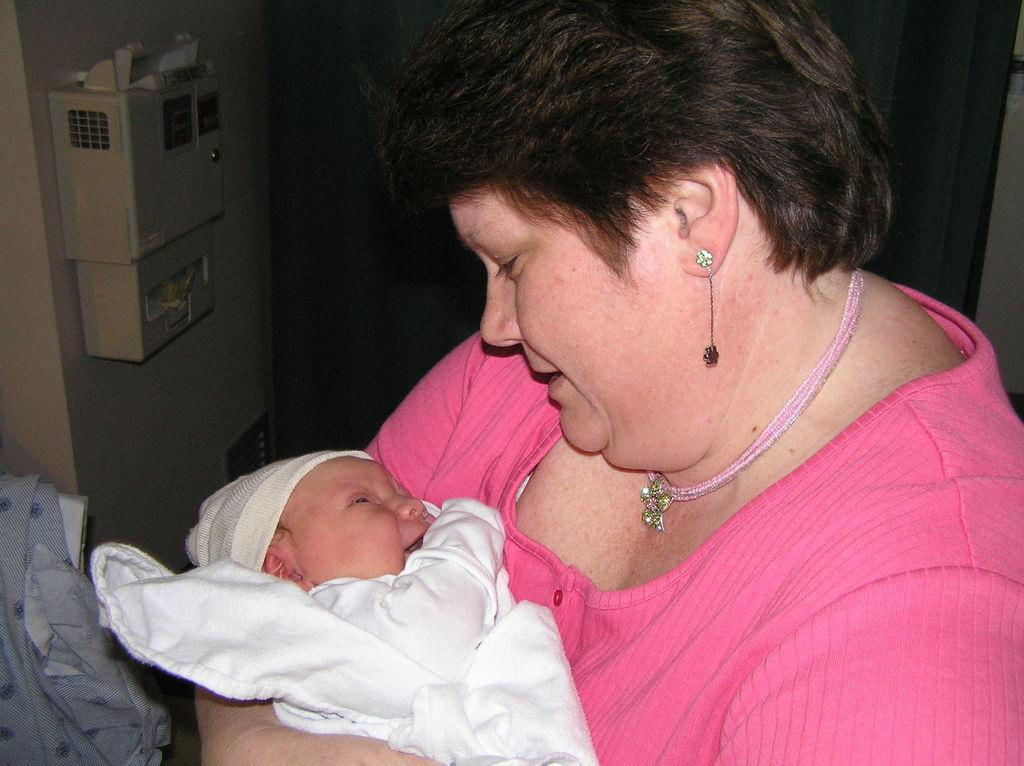What is the woman in the image doing? The woman is carrying a baby in the image. What can be seen behind the woman? There is a wall behind the woman. What is on the wall is located on the left side of the image? There is a box on the wall on the left side of the image. What is visible in the bottom left corner of the image? There is a cloth visible in the bottom left of the image. How many snakes are crawling on the wall in the image? There are no snakes present in the image; the wall has a box on it. What is the title of the image? The provided facts do not mention a title for the image. 